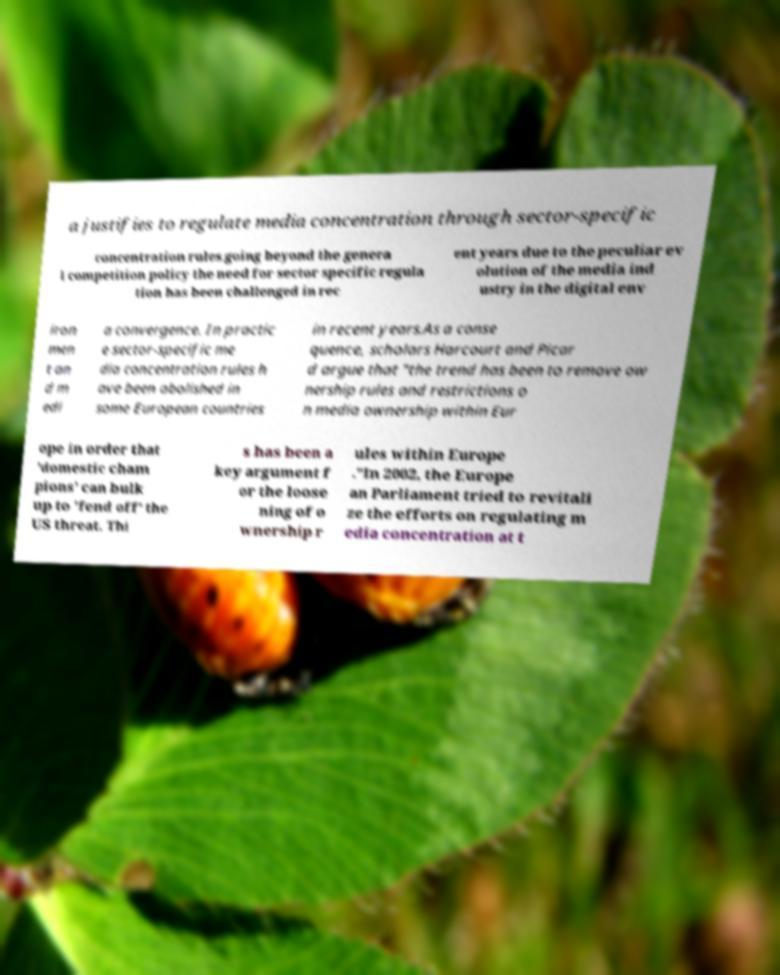Please read and relay the text visible in this image. What does it say? a justifies to regulate media concentration through sector-specific concentration rules going beyond the genera l competition policy the need for sector specific regula tion has been challenged in rec ent years due to the peculiar ev olution of the media ind ustry in the digital env iron men t an d m edi a convergence. In practic e sector-specific me dia concentration rules h ave been abolished in some European countries in recent years.As a conse quence, scholars Harcourt and Picar d argue that "the trend has been to remove ow nership rules and restrictions o n media ownership within Eur ope in order that 'domestic cham pions' can bulk up to 'fend off' the US threat. Thi s has been a key argument f or the loose ning of o wnership r ules within Europe ."In 2002, the Europe an Parliament tried to revitali ze the efforts on regulating m edia concentration at t 